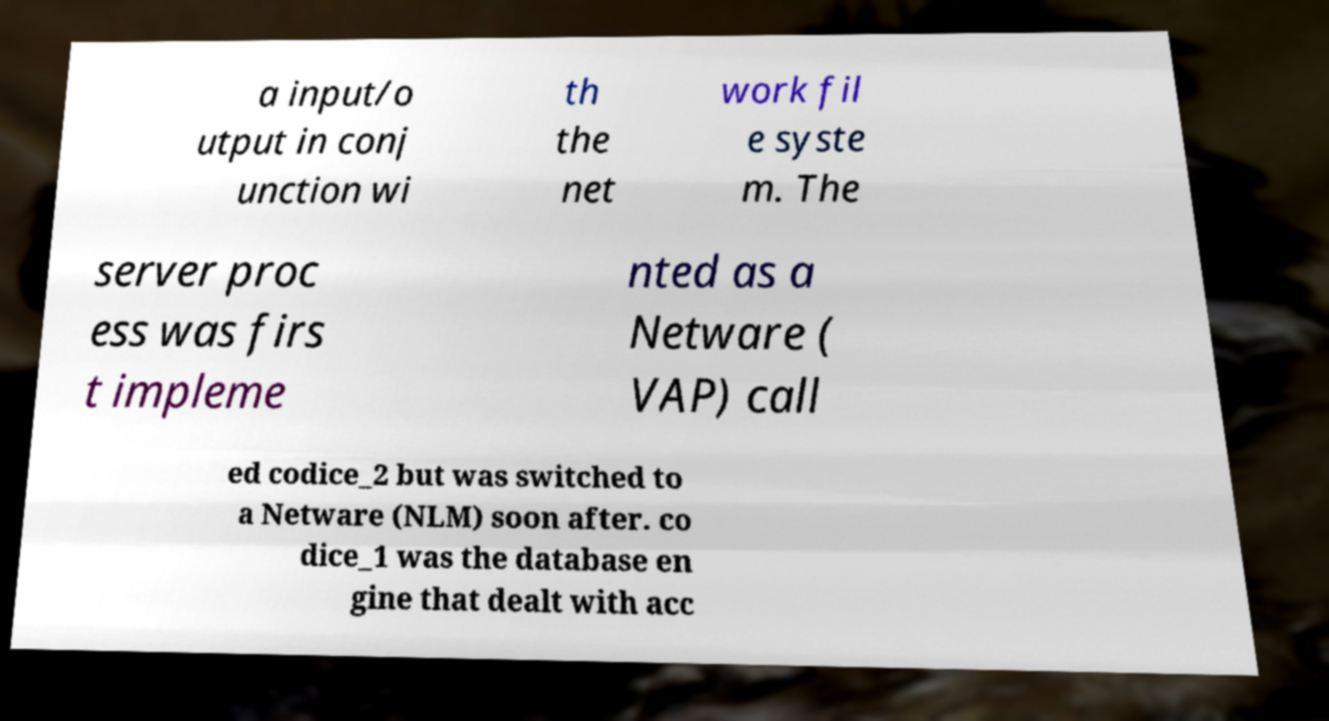Please read and relay the text visible in this image. What does it say? a input/o utput in conj unction wi th the net work fil e syste m. The server proc ess was firs t impleme nted as a Netware ( VAP) call ed codice_2 but was switched to a Netware (NLM) soon after. co dice_1 was the database en gine that dealt with acc 